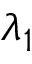Convert formula to latex. <formula><loc_0><loc_0><loc_500><loc_500>\lambda _ { 1 }</formula> 